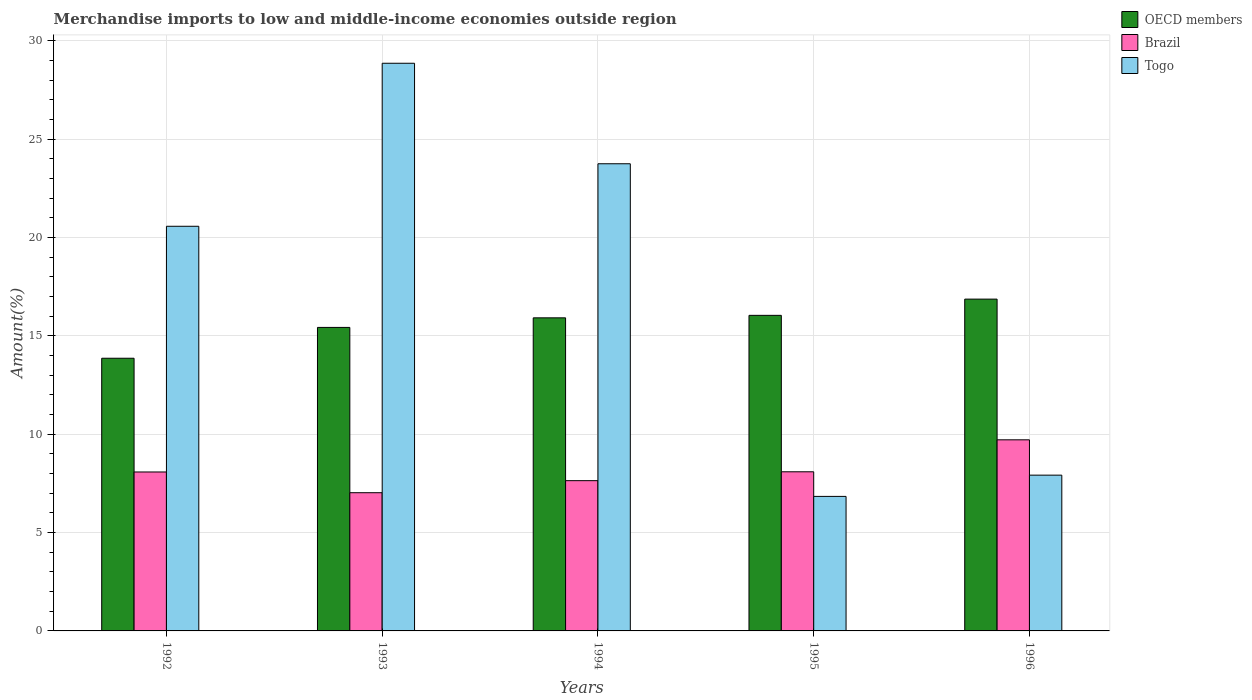How many different coloured bars are there?
Your response must be concise. 3. How many groups of bars are there?
Provide a short and direct response. 5. Are the number of bars per tick equal to the number of legend labels?
Keep it short and to the point. Yes. Are the number of bars on each tick of the X-axis equal?
Give a very brief answer. Yes. How many bars are there on the 3rd tick from the left?
Your answer should be very brief. 3. How many bars are there on the 5th tick from the right?
Ensure brevity in your answer.  3. What is the label of the 1st group of bars from the left?
Your response must be concise. 1992. What is the percentage of amount earned from merchandise imports in OECD members in 1994?
Offer a very short reply. 15.92. Across all years, what is the maximum percentage of amount earned from merchandise imports in OECD members?
Keep it short and to the point. 16.87. Across all years, what is the minimum percentage of amount earned from merchandise imports in Brazil?
Offer a terse response. 7.03. In which year was the percentage of amount earned from merchandise imports in OECD members minimum?
Give a very brief answer. 1992. What is the total percentage of amount earned from merchandise imports in Togo in the graph?
Offer a very short reply. 87.94. What is the difference between the percentage of amount earned from merchandise imports in OECD members in 1992 and that in 1995?
Provide a short and direct response. -2.18. What is the difference between the percentage of amount earned from merchandise imports in Brazil in 1992 and the percentage of amount earned from merchandise imports in OECD members in 1995?
Ensure brevity in your answer.  -7.96. What is the average percentage of amount earned from merchandise imports in Brazil per year?
Make the answer very short. 8.11. In the year 1996, what is the difference between the percentage of amount earned from merchandise imports in Brazil and percentage of amount earned from merchandise imports in Togo?
Offer a very short reply. 1.8. What is the ratio of the percentage of amount earned from merchandise imports in Togo in 1993 to that in 1995?
Ensure brevity in your answer.  4.22. What is the difference between the highest and the second highest percentage of amount earned from merchandise imports in Brazil?
Ensure brevity in your answer.  1.62. What is the difference between the highest and the lowest percentage of amount earned from merchandise imports in Togo?
Offer a very short reply. 22.02. In how many years, is the percentage of amount earned from merchandise imports in OECD members greater than the average percentage of amount earned from merchandise imports in OECD members taken over all years?
Offer a terse response. 3. What does the 3rd bar from the left in 1993 represents?
Your response must be concise. Togo. Is it the case that in every year, the sum of the percentage of amount earned from merchandise imports in Brazil and percentage of amount earned from merchandise imports in Togo is greater than the percentage of amount earned from merchandise imports in OECD members?
Give a very brief answer. No. How many bars are there?
Your response must be concise. 15. Are all the bars in the graph horizontal?
Make the answer very short. No. How many years are there in the graph?
Keep it short and to the point. 5. What is the difference between two consecutive major ticks on the Y-axis?
Keep it short and to the point. 5. Are the values on the major ticks of Y-axis written in scientific E-notation?
Your answer should be very brief. No. Does the graph contain any zero values?
Give a very brief answer. No. Where does the legend appear in the graph?
Your answer should be compact. Top right. How are the legend labels stacked?
Your answer should be compact. Vertical. What is the title of the graph?
Give a very brief answer. Merchandise imports to low and middle-income economies outside region. What is the label or title of the Y-axis?
Make the answer very short. Amount(%). What is the Amount(%) in OECD members in 1992?
Ensure brevity in your answer.  13.86. What is the Amount(%) of Brazil in 1992?
Ensure brevity in your answer.  8.08. What is the Amount(%) of Togo in 1992?
Your answer should be very brief. 20.57. What is the Amount(%) of OECD members in 1993?
Your answer should be compact. 15.43. What is the Amount(%) of Brazil in 1993?
Your response must be concise. 7.03. What is the Amount(%) of Togo in 1993?
Offer a terse response. 28.86. What is the Amount(%) in OECD members in 1994?
Your answer should be compact. 15.92. What is the Amount(%) in Brazil in 1994?
Offer a terse response. 7.64. What is the Amount(%) of Togo in 1994?
Make the answer very short. 23.75. What is the Amount(%) of OECD members in 1995?
Provide a succinct answer. 16.04. What is the Amount(%) of Brazil in 1995?
Your answer should be compact. 8.09. What is the Amount(%) of Togo in 1995?
Provide a short and direct response. 6.84. What is the Amount(%) of OECD members in 1996?
Offer a terse response. 16.87. What is the Amount(%) in Brazil in 1996?
Your response must be concise. 9.72. What is the Amount(%) of Togo in 1996?
Provide a short and direct response. 7.92. Across all years, what is the maximum Amount(%) in OECD members?
Your response must be concise. 16.87. Across all years, what is the maximum Amount(%) of Brazil?
Provide a short and direct response. 9.72. Across all years, what is the maximum Amount(%) of Togo?
Provide a succinct answer. 28.86. Across all years, what is the minimum Amount(%) of OECD members?
Keep it short and to the point. 13.86. Across all years, what is the minimum Amount(%) of Brazil?
Offer a very short reply. 7.03. Across all years, what is the minimum Amount(%) in Togo?
Your answer should be compact. 6.84. What is the total Amount(%) in OECD members in the graph?
Keep it short and to the point. 78.12. What is the total Amount(%) of Brazil in the graph?
Provide a succinct answer. 40.55. What is the total Amount(%) of Togo in the graph?
Give a very brief answer. 87.94. What is the difference between the Amount(%) in OECD members in 1992 and that in 1993?
Your response must be concise. -1.57. What is the difference between the Amount(%) in Brazil in 1992 and that in 1993?
Your response must be concise. 1.05. What is the difference between the Amount(%) of Togo in 1992 and that in 1993?
Your answer should be compact. -8.29. What is the difference between the Amount(%) of OECD members in 1992 and that in 1994?
Offer a terse response. -2.05. What is the difference between the Amount(%) in Brazil in 1992 and that in 1994?
Give a very brief answer. 0.44. What is the difference between the Amount(%) of Togo in 1992 and that in 1994?
Provide a short and direct response. -3.18. What is the difference between the Amount(%) in OECD members in 1992 and that in 1995?
Keep it short and to the point. -2.18. What is the difference between the Amount(%) of Brazil in 1992 and that in 1995?
Ensure brevity in your answer.  -0.01. What is the difference between the Amount(%) of Togo in 1992 and that in 1995?
Your answer should be compact. 13.73. What is the difference between the Amount(%) of OECD members in 1992 and that in 1996?
Keep it short and to the point. -3.01. What is the difference between the Amount(%) in Brazil in 1992 and that in 1996?
Your response must be concise. -1.64. What is the difference between the Amount(%) in Togo in 1992 and that in 1996?
Offer a very short reply. 12.65. What is the difference between the Amount(%) in OECD members in 1993 and that in 1994?
Your response must be concise. -0.49. What is the difference between the Amount(%) of Brazil in 1993 and that in 1994?
Make the answer very short. -0.61. What is the difference between the Amount(%) of Togo in 1993 and that in 1994?
Your response must be concise. 5.11. What is the difference between the Amount(%) in OECD members in 1993 and that in 1995?
Make the answer very short. -0.61. What is the difference between the Amount(%) of Brazil in 1993 and that in 1995?
Ensure brevity in your answer.  -1.06. What is the difference between the Amount(%) of Togo in 1993 and that in 1995?
Provide a succinct answer. 22.02. What is the difference between the Amount(%) in OECD members in 1993 and that in 1996?
Ensure brevity in your answer.  -1.44. What is the difference between the Amount(%) in Brazil in 1993 and that in 1996?
Keep it short and to the point. -2.69. What is the difference between the Amount(%) of Togo in 1993 and that in 1996?
Make the answer very short. 20.94. What is the difference between the Amount(%) of OECD members in 1994 and that in 1995?
Provide a short and direct response. -0.13. What is the difference between the Amount(%) in Brazil in 1994 and that in 1995?
Your response must be concise. -0.45. What is the difference between the Amount(%) of Togo in 1994 and that in 1995?
Your answer should be very brief. 16.91. What is the difference between the Amount(%) of OECD members in 1994 and that in 1996?
Offer a very short reply. -0.95. What is the difference between the Amount(%) of Brazil in 1994 and that in 1996?
Your answer should be compact. -2.08. What is the difference between the Amount(%) of Togo in 1994 and that in 1996?
Provide a short and direct response. 15.83. What is the difference between the Amount(%) in OECD members in 1995 and that in 1996?
Your response must be concise. -0.83. What is the difference between the Amount(%) in Brazil in 1995 and that in 1996?
Keep it short and to the point. -1.62. What is the difference between the Amount(%) in Togo in 1995 and that in 1996?
Ensure brevity in your answer.  -1.08. What is the difference between the Amount(%) in OECD members in 1992 and the Amount(%) in Brazil in 1993?
Keep it short and to the point. 6.84. What is the difference between the Amount(%) in OECD members in 1992 and the Amount(%) in Togo in 1993?
Provide a succinct answer. -15. What is the difference between the Amount(%) in Brazil in 1992 and the Amount(%) in Togo in 1993?
Offer a terse response. -20.78. What is the difference between the Amount(%) of OECD members in 1992 and the Amount(%) of Brazil in 1994?
Offer a very short reply. 6.22. What is the difference between the Amount(%) of OECD members in 1992 and the Amount(%) of Togo in 1994?
Offer a terse response. -9.89. What is the difference between the Amount(%) of Brazil in 1992 and the Amount(%) of Togo in 1994?
Give a very brief answer. -15.67. What is the difference between the Amount(%) of OECD members in 1992 and the Amount(%) of Brazil in 1995?
Offer a terse response. 5.77. What is the difference between the Amount(%) in OECD members in 1992 and the Amount(%) in Togo in 1995?
Give a very brief answer. 7.02. What is the difference between the Amount(%) in Brazil in 1992 and the Amount(%) in Togo in 1995?
Give a very brief answer. 1.24. What is the difference between the Amount(%) in OECD members in 1992 and the Amount(%) in Brazil in 1996?
Offer a very short reply. 4.15. What is the difference between the Amount(%) in OECD members in 1992 and the Amount(%) in Togo in 1996?
Provide a short and direct response. 5.94. What is the difference between the Amount(%) in Brazil in 1992 and the Amount(%) in Togo in 1996?
Offer a very short reply. 0.16. What is the difference between the Amount(%) of OECD members in 1993 and the Amount(%) of Brazil in 1994?
Provide a succinct answer. 7.79. What is the difference between the Amount(%) of OECD members in 1993 and the Amount(%) of Togo in 1994?
Provide a succinct answer. -8.32. What is the difference between the Amount(%) of Brazil in 1993 and the Amount(%) of Togo in 1994?
Your response must be concise. -16.72. What is the difference between the Amount(%) in OECD members in 1993 and the Amount(%) in Brazil in 1995?
Provide a succinct answer. 7.34. What is the difference between the Amount(%) of OECD members in 1993 and the Amount(%) of Togo in 1995?
Your response must be concise. 8.59. What is the difference between the Amount(%) of Brazil in 1993 and the Amount(%) of Togo in 1995?
Make the answer very short. 0.19. What is the difference between the Amount(%) in OECD members in 1993 and the Amount(%) in Brazil in 1996?
Keep it short and to the point. 5.71. What is the difference between the Amount(%) in OECD members in 1993 and the Amount(%) in Togo in 1996?
Your answer should be very brief. 7.51. What is the difference between the Amount(%) of Brazil in 1993 and the Amount(%) of Togo in 1996?
Your answer should be compact. -0.89. What is the difference between the Amount(%) in OECD members in 1994 and the Amount(%) in Brazil in 1995?
Keep it short and to the point. 7.83. What is the difference between the Amount(%) in OECD members in 1994 and the Amount(%) in Togo in 1995?
Keep it short and to the point. 9.08. What is the difference between the Amount(%) in Brazil in 1994 and the Amount(%) in Togo in 1995?
Keep it short and to the point. 0.8. What is the difference between the Amount(%) in OECD members in 1994 and the Amount(%) in Brazil in 1996?
Your answer should be compact. 6.2. What is the difference between the Amount(%) of OECD members in 1994 and the Amount(%) of Togo in 1996?
Ensure brevity in your answer.  8. What is the difference between the Amount(%) in Brazil in 1994 and the Amount(%) in Togo in 1996?
Offer a very short reply. -0.28. What is the difference between the Amount(%) of OECD members in 1995 and the Amount(%) of Brazil in 1996?
Your answer should be very brief. 6.33. What is the difference between the Amount(%) in OECD members in 1995 and the Amount(%) in Togo in 1996?
Your response must be concise. 8.12. What is the difference between the Amount(%) in Brazil in 1995 and the Amount(%) in Togo in 1996?
Provide a succinct answer. 0.17. What is the average Amount(%) of OECD members per year?
Provide a succinct answer. 15.62. What is the average Amount(%) of Brazil per year?
Ensure brevity in your answer.  8.11. What is the average Amount(%) in Togo per year?
Make the answer very short. 17.59. In the year 1992, what is the difference between the Amount(%) in OECD members and Amount(%) in Brazil?
Your answer should be compact. 5.78. In the year 1992, what is the difference between the Amount(%) of OECD members and Amount(%) of Togo?
Make the answer very short. -6.71. In the year 1992, what is the difference between the Amount(%) of Brazil and Amount(%) of Togo?
Make the answer very short. -12.49. In the year 1993, what is the difference between the Amount(%) in OECD members and Amount(%) in Brazil?
Make the answer very short. 8.4. In the year 1993, what is the difference between the Amount(%) of OECD members and Amount(%) of Togo?
Your answer should be compact. -13.43. In the year 1993, what is the difference between the Amount(%) of Brazil and Amount(%) of Togo?
Provide a short and direct response. -21.83. In the year 1994, what is the difference between the Amount(%) in OECD members and Amount(%) in Brazil?
Your response must be concise. 8.28. In the year 1994, what is the difference between the Amount(%) in OECD members and Amount(%) in Togo?
Your answer should be compact. -7.83. In the year 1994, what is the difference between the Amount(%) of Brazil and Amount(%) of Togo?
Your answer should be very brief. -16.11. In the year 1995, what is the difference between the Amount(%) in OECD members and Amount(%) in Brazil?
Your answer should be very brief. 7.95. In the year 1995, what is the difference between the Amount(%) in OECD members and Amount(%) in Togo?
Your answer should be compact. 9.2. In the year 1995, what is the difference between the Amount(%) in Brazil and Amount(%) in Togo?
Make the answer very short. 1.25. In the year 1996, what is the difference between the Amount(%) in OECD members and Amount(%) in Brazil?
Offer a very short reply. 7.15. In the year 1996, what is the difference between the Amount(%) of OECD members and Amount(%) of Togo?
Give a very brief answer. 8.95. In the year 1996, what is the difference between the Amount(%) of Brazil and Amount(%) of Togo?
Provide a short and direct response. 1.8. What is the ratio of the Amount(%) of OECD members in 1992 to that in 1993?
Your response must be concise. 0.9. What is the ratio of the Amount(%) in Brazil in 1992 to that in 1993?
Your answer should be very brief. 1.15. What is the ratio of the Amount(%) in Togo in 1992 to that in 1993?
Your response must be concise. 0.71. What is the ratio of the Amount(%) of OECD members in 1992 to that in 1994?
Make the answer very short. 0.87. What is the ratio of the Amount(%) of Brazil in 1992 to that in 1994?
Offer a very short reply. 1.06. What is the ratio of the Amount(%) in Togo in 1992 to that in 1994?
Your answer should be compact. 0.87. What is the ratio of the Amount(%) in OECD members in 1992 to that in 1995?
Your response must be concise. 0.86. What is the ratio of the Amount(%) of Brazil in 1992 to that in 1995?
Offer a terse response. 1. What is the ratio of the Amount(%) in Togo in 1992 to that in 1995?
Offer a terse response. 3.01. What is the ratio of the Amount(%) of OECD members in 1992 to that in 1996?
Your answer should be compact. 0.82. What is the ratio of the Amount(%) in Brazil in 1992 to that in 1996?
Your response must be concise. 0.83. What is the ratio of the Amount(%) in Togo in 1992 to that in 1996?
Ensure brevity in your answer.  2.6. What is the ratio of the Amount(%) in OECD members in 1993 to that in 1994?
Provide a short and direct response. 0.97. What is the ratio of the Amount(%) in Brazil in 1993 to that in 1994?
Make the answer very short. 0.92. What is the ratio of the Amount(%) of Togo in 1993 to that in 1994?
Your answer should be compact. 1.22. What is the ratio of the Amount(%) in OECD members in 1993 to that in 1995?
Offer a very short reply. 0.96. What is the ratio of the Amount(%) in Brazil in 1993 to that in 1995?
Your answer should be compact. 0.87. What is the ratio of the Amount(%) of Togo in 1993 to that in 1995?
Make the answer very short. 4.22. What is the ratio of the Amount(%) of OECD members in 1993 to that in 1996?
Offer a terse response. 0.91. What is the ratio of the Amount(%) of Brazil in 1993 to that in 1996?
Keep it short and to the point. 0.72. What is the ratio of the Amount(%) in Togo in 1993 to that in 1996?
Make the answer very short. 3.64. What is the ratio of the Amount(%) in OECD members in 1994 to that in 1995?
Offer a terse response. 0.99. What is the ratio of the Amount(%) of Brazil in 1994 to that in 1995?
Give a very brief answer. 0.94. What is the ratio of the Amount(%) of Togo in 1994 to that in 1995?
Offer a terse response. 3.47. What is the ratio of the Amount(%) of OECD members in 1994 to that in 1996?
Make the answer very short. 0.94. What is the ratio of the Amount(%) of Brazil in 1994 to that in 1996?
Ensure brevity in your answer.  0.79. What is the ratio of the Amount(%) in Togo in 1994 to that in 1996?
Provide a short and direct response. 3. What is the ratio of the Amount(%) in OECD members in 1995 to that in 1996?
Offer a very short reply. 0.95. What is the ratio of the Amount(%) in Brazil in 1995 to that in 1996?
Your answer should be very brief. 0.83. What is the ratio of the Amount(%) in Togo in 1995 to that in 1996?
Give a very brief answer. 0.86. What is the difference between the highest and the second highest Amount(%) in OECD members?
Make the answer very short. 0.83. What is the difference between the highest and the second highest Amount(%) of Brazil?
Offer a very short reply. 1.62. What is the difference between the highest and the second highest Amount(%) of Togo?
Ensure brevity in your answer.  5.11. What is the difference between the highest and the lowest Amount(%) of OECD members?
Offer a very short reply. 3.01. What is the difference between the highest and the lowest Amount(%) in Brazil?
Provide a short and direct response. 2.69. What is the difference between the highest and the lowest Amount(%) of Togo?
Give a very brief answer. 22.02. 